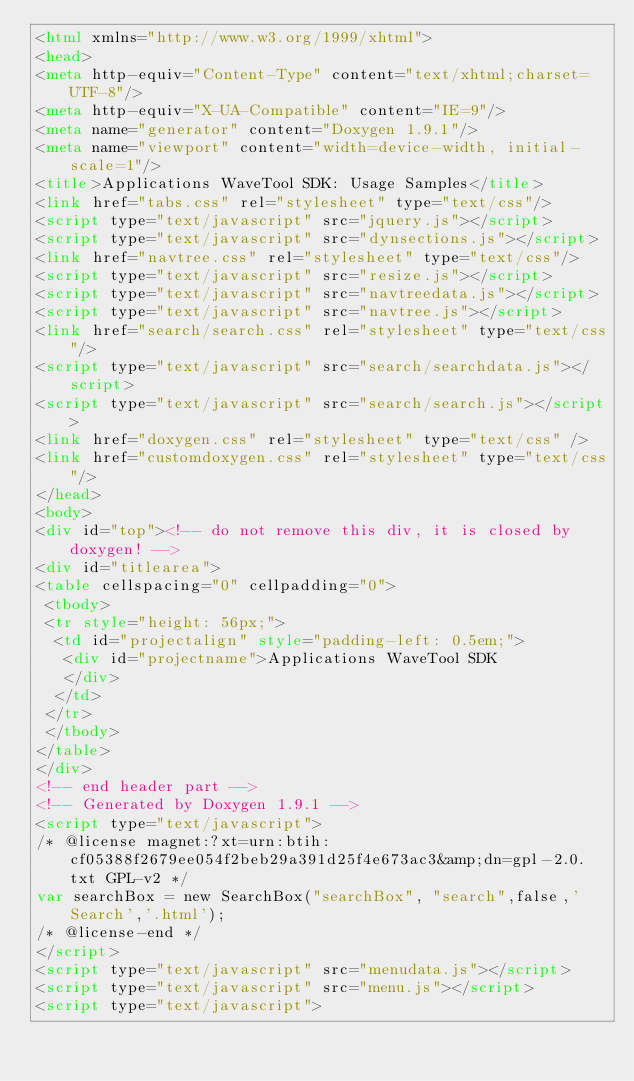<code> <loc_0><loc_0><loc_500><loc_500><_HTML_><html xmlns="http://www.w3.org/1999/xhtml">
<head>
<meta http-equiv="Content-Type" content="text/xhtml;charset=UTF-8"/>
<meta http-equiv="X-UA-Compatible" content="IE=9"/>
<meta name="generator" content="Doxygen 1.9.1"/>
<meta name="viewport" content="width=device-width, initial-scale=1"/>
<title>Applications WaveTool SDK: Usage Samples</title>
<link href="tabs.css" rel="stylesheet" type="text/css"/>
<script type="text/javascript" src="jquery.js"></script>
<script type="text/javascript" src="dynsections.js"></script>
<link href="navtree.css" rel="stylesheet" type="text/css"/>
<script type="text/javascript" src="resize.js"></script>
<script type="text/javascript" src="navtreedata.js"></script>
<script type="text/javascript" src="navtree.js"></script>
<link href="search/search.css" rel="stylesheet" type="text/css"/>
<script type="text/javascript" src="search/searchdata.js"></script>
<script type="text/javascript" src="search/search.js"></script>
<link href="doxygen.css" rel="stylesheet" type="text/css" />
<link href="customdoxygen.css" rel="stylesheet" type="text/css"/>
</head>
<body>
<div id="top"><!-- do not remove this div, it is closed by doxygen! -->
<div id="titlearea">
<table cellspacing="0" cellpadding="0">
 <tbody>
 <tr style="height: 56px;">
  <td id="projectalign" style="padding-left: 0.5em;">
   <div id="projectname">Applications WaveTool SDK
   </div>
  </td>
 </tr>
 </tbody>
</table>
</div>
<!-- end header part -->
<!-- Generated by Doxygen 1.9.1 -->
<script type="text/javascript">
/* @license magnet:?xt=urn:btih:cf05388f2679ee054f2beb29a391d25f4e673ac3&amp;dn=gpl-2.0.txt GPL-v2 */
var searchBox = new SearchBox("searchBox", "search",false,'Search','.html');
/* @license-end */
</script>
<script type="text/javascript" src="menudata.js"></script>
<script type="text/javascript" src="menu.js"></script>
<script type="text/javascript"></code> 